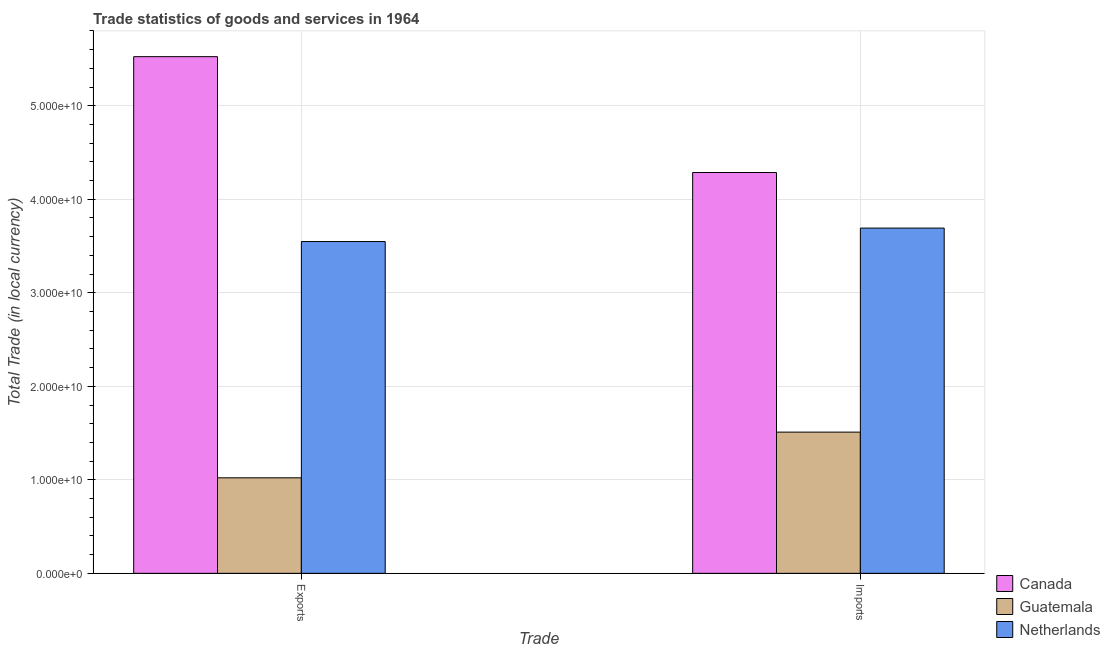How many different coloured bars are there?
Offer a very short reply. 3. Are the number of bars on each tick of the X-axis equal?
Offer a very short reply. Yes. What is the label of the 1st group of bars from the left?
Offer a very short reply. Exports. What is the imports of goods and services in Canada?
Your response must be concise. 4.29e+1. Across all countries, what is the maximum imports of goods and services?
Offer a very short reply. 4.29e+1. Across all countries, what is the minimum export of goods and services?
Offer a terse response. 1.02e+1. In which country was the export of goods and services maximum?
Make the answer very short. Canada. In which country was the imports of goods and services minimum?
Give a very brief answer. Guatemala. What is the total imports of goods and services in the graph?
Offer a terse response. 9.49e+1. What is the difference between the export of goods and services in Guatemala and that in Netherlands?
Your answer should be compact. -2.53e+1. What is the difference between the export of goods and services in Guatemala and the imports of goods and services in Netherlands?
Your response must be concise. -2.67e+1. What is the average imports of goods and services per country?
Give a very brief answer. 3.16e+1. What is the difference between the export of goods and services and imports of goods and services in Netherlands?
Provide a succinct answer. -1.44e+09. In how many countries, is the imports of goods and services greater than 42000000000 LCU?
Give a very brief answer. 1. What is the ratio of the export of goods and services in Netherlands to that in Canada?
Provide a succinct answer. 0.64. What does the 1st bar from the left in Exports represents?
Provide a short and direct response. Canada. What does the 3rd bar from the right in Imports represents?
Provide a succinct answer. Canada. How many bars are there?
Keep it short and to the point. 6. How many countries are there in the graph?
Provide a succinct answer. 3. What is the difference between two consecutive major ticks on the Y-axis?
Your answer should be compact. 1.00e+1. Does the graph contain any zero values?
Give a very brief answer. No. Where does the legend appear in the graph?
Provide a short and direct response. Bottom right. How many legend labels are there?
Offer a very short reply. 3. What is the title of the graph?
Your answer should be very brief. Trade statistics of goods and services in 1964. What is the label or title of the X-axis?
Your answer should be very brief. Trade. What is the label or title of the Y-axis?
Offer a very short reply. Total Trade (in local currency). What is the Total Trade (in local currency) of Canada in Exports?
Make the answer very short. 5.52e+1. What is the Total Trade (in local currency) of Guatemala in Exports?
Your response must be concise. 1.02e+1. What is the Total Trade (in local currency) of Netherlands in Exports?
Ensure brevity in your answer.  3.55e+1. What is the Total Trade (in local currency) of Canada in Imports?
Your answer should be compact. 4.29e+1. What is the Total Trade (in local currency) of Guatemala in Imports?
Ensure brevity in your answer.  1.51e+1. What is the Total Trade (in local currency) of Netherlands in Imports?
Make the answer very short. 3.69e+1. Across all Trade, what is the maximum Total Trade (in local currency) of Canada?
Ensure brevity in your answer.  5.52e+1. Across all Trade, what is the maximum Total Trade (in local currency) of Guatemala?
Keep it short and to the point. 1.51e+1. Across all Trade, what is the maximum Total Trade (in local currency) of Netherlands?
Offer a terse response. 3.69e+1. Across all Trade, what is the minimum Total Trade (in local currency) of Canada?
Your response must be concise. 4.29e+1. Across all Trade, what is the minimum Total Trade (in local currency) in Guatemala?
Keep it short and to the point. 1.02e+1. Across all Trade, what is the minimum Total Trade (in local currency) of Netherlands?
Provide a succinct answer. 3.55e+1. What is the total Total Trade (in local currency) of Canada in the graph?
Keep it short and to the point. 9.81e+1. What is the total Total Trade (in local currency) in Guatemala in the graph?
Your answer should be very brief. 2.53e+1. What is the total Total Trade (in local currency) in Netherlands in the graph?
Ensure brevity in your answer.  7.24e+1. What is the difference between the Total Trade (in local currency) in Canada in Exports and that in Imports?
Keep it short and to the point. 1.24e+1. What is the difference between the Total Trade (in local currency) of Guatemala in Exports and that in Imports?
Ensure brevity in your answer.  -4.89e+09. What is the difference between the Total Trade (in local currency) in Netherlands in Exports and that in Imports?
Provide a short and direct response. -1.44e+09. What is the difference between the Total Trade (in local currency) of Canada in Exports and the Total Trade (in local currency) of Guatemala in Imports?
Provide a short and direct response. 4.01e+1. What is the difference between the Total Trade (in local currency) of Canada in Exports and the Total Trade (in local currency) of Netherlands in Imports?
Your answer should be compact. 1.83e+1. What is the difference between the Total Trade (in local currency) in Guatemala in Exports and the Total Trade (in local currency) in Netherlands in Imports?
Your answer should be very brief. -2.67e+1. What is the average Total Trade (in local currency) in Canada per Trade?
Your response must be concise. 4.91e+1. What is the average Total Trade (in local currency) of Guatemala per Trade?
Provide a succinct answer. 1.27e+1. What is the average Total Trade (in local currency) of Netherlands per Trade?
Give a very brief answer. 3.62e+1. What is the difference between the Total Trade (in local currency) in Canada and Total Trade (in local currency) in Guatemala in Exports?
Keep it short and to the point. 4.50e+1. What is the difference between the Total Trade (in local currency) in Canada and Total Trade (in local currency) in Netherlands in Exports?
Your response must be concise. 1.98e+1. What is the difference between the Total Trade (in local currency) in Guatemala and Total Trade (in local currency) in Netherlands in Exports?
Make the answer very short. -2.53e+1. What is the difference between the Total Trade (in local currency) of Canada and Total Trade (in local currency) of Guatemala in Imports?
Offer a terse response. 2.78e+1. What is the difference between the Total Trade (in local currency) of Canada and Total Trade (in local currency) of Netherlands in Imports?
Ensure brevity in your answer.  5.94e+09. What is the difference between the Total Trade (in local currency) in Guatemala and Total Trade (in local currency) in Netherlands in Imports?
Offer a very short reply. -2.18e+1. What is the ratio of the Total Trade (in local currency) of Canada in Exports to that in Imports?
Give a very brief answer. 1.29. What is the ratio of the Total Trade (in local currency) in Guatemala in Exports to that in Imports?
Offer a very short reply. 0.68. What is the ratio of the Total Trade (in local currency) in Netherlands in Exports to that in Imports?
Give a very brief answer. 0.96. What is the difference between the highest and the second highest Total Trade (in local currency) in Canada?
Keep it short and to the point. 1.24e+1. What is the difference between the highest and the second highest Total Trade (in local currency) of Guatemala?
Ensure brevity in your answer.  4.89e+09. What is the difference between the highest and the second highest Total Trade (in local currency) of Netherlands?
Your response must be concise. 1.44e+09. What is the difference between the highest and the lowest Total Trade (in local currency) in Canada?
Ensure brevity in your answer.  1.24e+1. What is the difference between the highest and the lowest Total Trade (in local currency) in Guatemala?
Give a very brief answer. 4.89e+09. What is the difference between the highest and the lowest Total Trade (in local currency) in Netherlands?
Provide a short and direct response. 1.44e+09. 